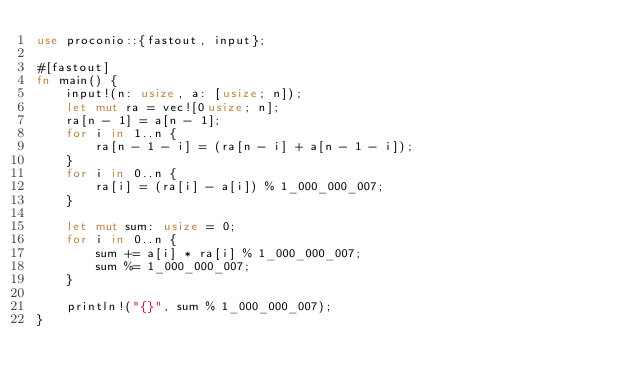Convert code to text. <code><loc_0><loc_0><loc_500><loc_500><_Rust_>use proconio::{fastout, input};

#[fastout]
fn main() {
    input!(n: usize, a: [usize; n]);
    let mut ra = vec![0usize; n];
    ra[n - 1] = a[n - 1];
    for i in 1..n {
        ra[n - 1 - i] = (ra[n - i] + a[n - 1 - i]);
    }
    for i in 0..n {
        ra[i] = (ra[i] - a[i]) % 1_000_000_007;
    }

    let mut sum: usize = 0;
    for i in 0..n {
        sum += a[i] * ra[i] % 1_000_000_007;
        sum %= 1_000_000_007;
    }

    println!("{}", sum % 1_000_000_007);
}
</code> 